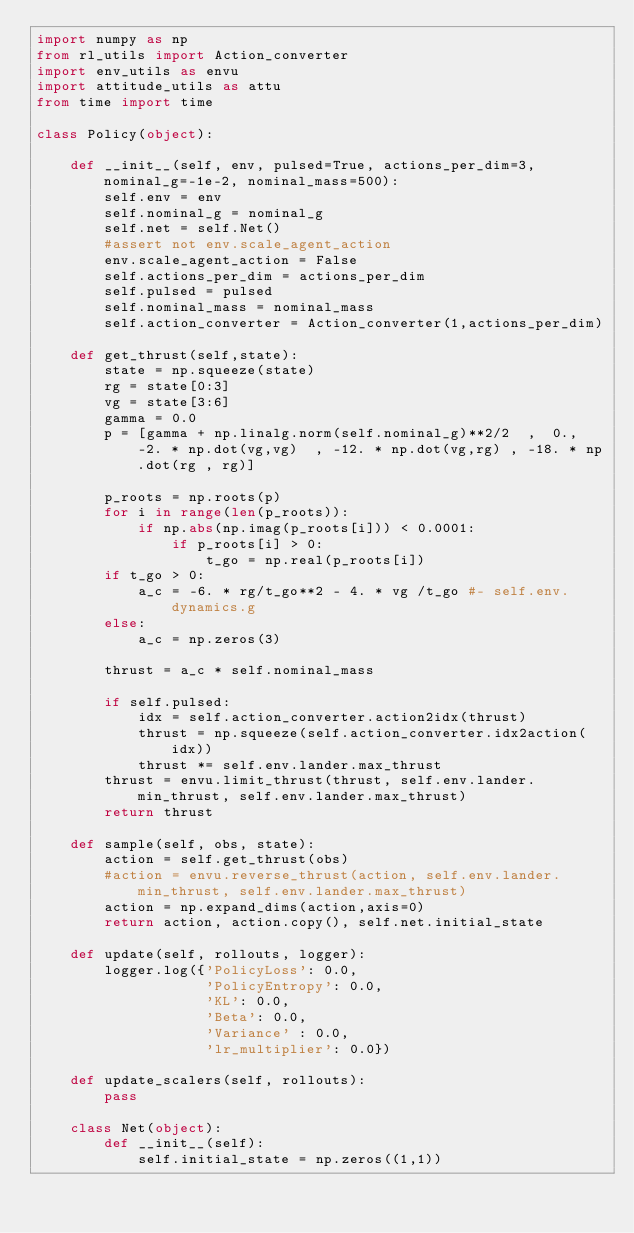Convert code to text. <code><loc_0><loc_0><loc_500><loc_500><_Python_>import numpy as np
from rl_utils import Action_converter
import env_utils as envu
import attitude_utils as attu
from time import time

class Policy(object):

    def __init__(self, env, pulsed=True, actions_per_dim=3, nominal_g=-1e-2, nominal_mass=500):
        self.env = env
        self.nominal_g = nominal_g 
        self.net = self.Net()
        #assert not env.scale_agent_action
        env.scale_agent_action = False
        self.actions_per_dim = actions_per_dim
        self.pulsed = pulsed
        self.nominal_mass = nominal_mass
        self.action_converter = Action_converter(1,actions_per_dim)

    def get_thrust(self,state):
        state = np.squeeze(state)
        rg = state[0:3]
        vg = state[3:6]
        gamma = 0.0
        p = [gamma + np.linalg.norm(self.nominal_g)**2/2  ,  0., -2. * np.dot(vg,vg)  , -12. * np.dot(vg,rg) , -18. * np.dot(rg , rg)]

        p_roots = np.roots(p)
        for i in range(len(p_roots)):
            if np.abs(np.imag(p_roots[i])) < 0.0001:
                if p_roots[i] > 0:
                    t_go = np.real(p_roots[i])
        if t_go > 0:
            a_c = -6. * rg/t_go**2 - 4. * vg /t_go #- self.env.dynamics.g
        else:
            a_c = np.zeros(3) 

        thrust = a_c * self.nominal_mass

        if self.pulsed:
            idx = self.action_converter.action2idx(thrust)
            thrust = np.squeeze(self.action_converter.idx2action(idx))
            thrust *= self.env.lander.max_thrust
        thrust = envu.limit_thrust(thrust, self.env.lander.min_thrust, self.env.lander.max_thrust)
        return thrust 

    def sample(self, obs, state):
        action = self.get_thrust(obs)
        #action = envu.reverse_thrust(action, self.env.lander.min_thrust, self.env.lander.max_thrust)
        action = np.expand_dims(action,axis=0)
        return action, action.copy(), self.net.initial_state

    def update(self, rollouts, logger): 
        logger.log({'PolicyLoss': 0.0,
                    'PolicyEntropy': 0.0,
                    'KL': 0.0,
                    'Beta': 0.0,
                    'Variance' : 0.0,
                    'lr_multiplier': 0.0})

    def update_scalers(self, rollouts):
        pass

    class Net(object):
        def __init__(self):
            self.initial_state = np.zeros((1,1))

</code> 